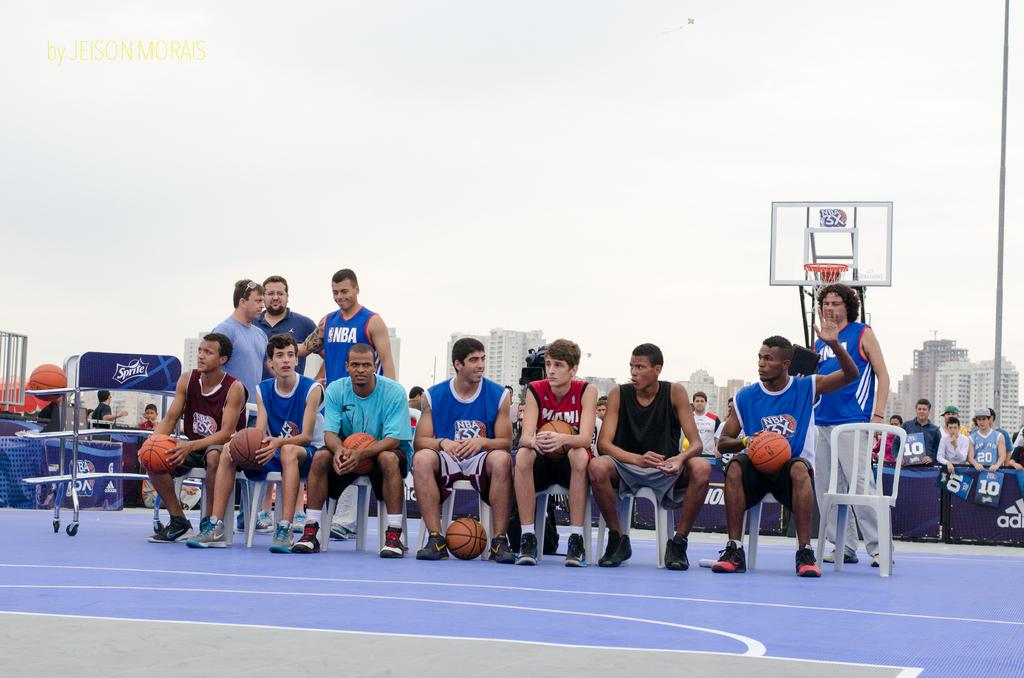<image>
Describe the image concisely. A team photograph of a young mens basketball team was taken by Jeison Morais. 